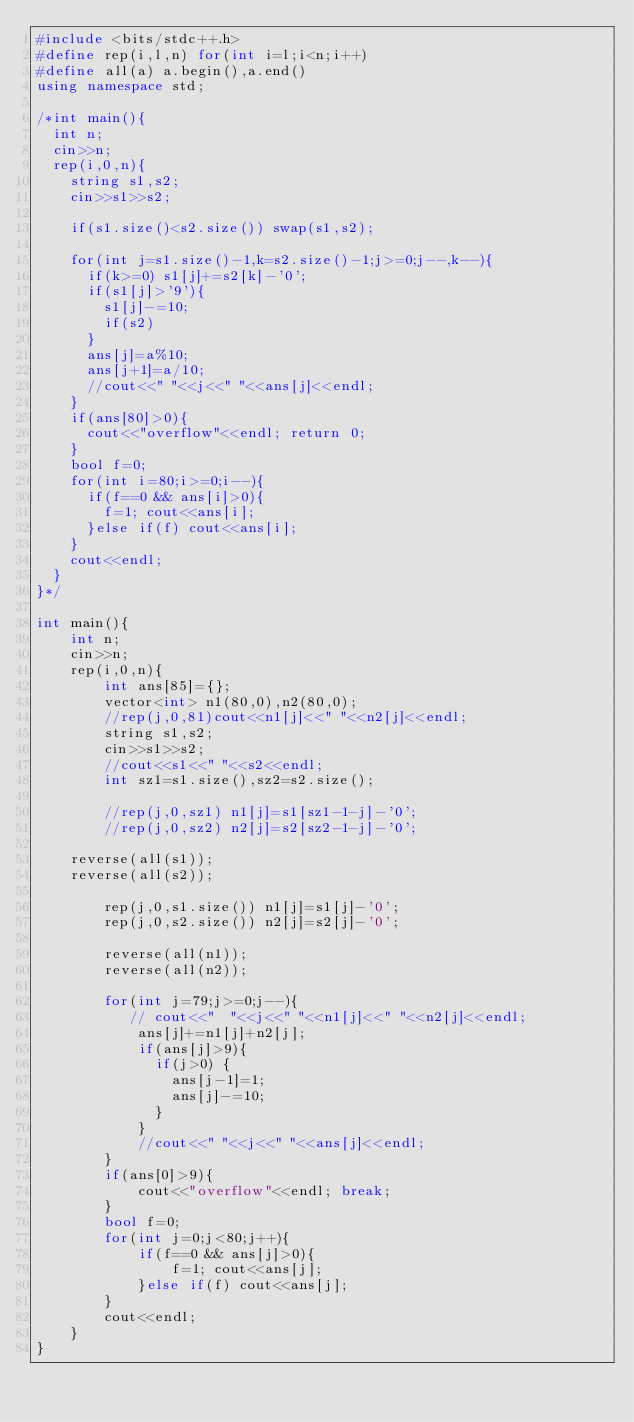Convert code to text. <code><loc_0><loc_0><loc_500><loc_500><_C++_>#include <bits/stdc++.h>
#define rep(i,l,n) for(int i=l;i<n;i++)
#define all(a) a.begin(),a.end()
using namespace std;

/*int main(){
	int n;
	cin>>n;
	rep(i,0,n){
		string s1,s2;
		cin>>s1>>s2;

		if(s1.size()<s2.size()) swap(s1,s2);

		for(int j=s1.size()-1,k=s2.size()-1;j>=0;j--,k--){
			if(k>=0) s1[j]+=s2[k]-'0';
			if(s1[j]>'9'){
				s1[j]-=10;
				if(s2)
			}
			ans[j]=a%10;
			ans[j+1]=a/10;
			//cout<<" "<<j<<" "<<ans[j]<<endl;
		}
		if(ans[80]>0){
			cout<<"overflow"<<endl; return 0;
		}
		bool f=0;
		for(int i=80;i>=0;i--){
			if(f==0 && ans[i]>0){
				f=1; cout<<ans[i];
			}else if(f) cout<<ans[i];
		}
		cout<<endl;
	}
}*/

int main(){
    int n;
    cin>>n;
    rep(i,0,n){
        int ans[85]={};
        vector<int> n1(80,0),n2(80,0);
        //rep(j,0,81)cout<<n1[j]<<" "<<n2[j]<<endl;
        string s1,s2; 
        cin>>s1>>s2;
        //cout<<s1<<" "<<s2<<endl;
        int sz1=s1.size(),sz2=s2.size();
 
        //rep(j,0,sz1) n1[j]=s1[sz1-1-j]-'0';
        //rep(j,0,sz2) n2[j]=s2[sz2-1-j]-'0';
 		
 		reverse(all(s1));
 		reverse(all(s2));

        rep(j,0,s1.size()) n1[j]=s1[j]-'0';
        rep(j,0,s2.size()) n2[j]=s2[j]-'0';

        reverse(all(n1));
        reverse(all(n2));

        for(int j=79;j>=0;j--){
           // cout<<"  "<<j<<" "<<n1[j]<<" "<<n2[j]<<endl;
            ans[j]+=n1[j]+n2[j];
            if(ans[j]>9){
            	if(j>0) {
            		ans[j-1]=1;
            		ans[j]-=10;
            	}
            }
            //cout<<" "<<j<<" "<<ans[j]<<endl;
        }
        if(ans[0]>9){
            cout<<"overflow"<<endl; break;
        }
        bool f=0;
        for(int j=0;j<80;j++){
            if(f==0 && ans[j]>0){
                f=1; cout<<ans[j];
            }else if(f) cout<<ans[j];
        }
        cout<<endl;
    }
}</code> 